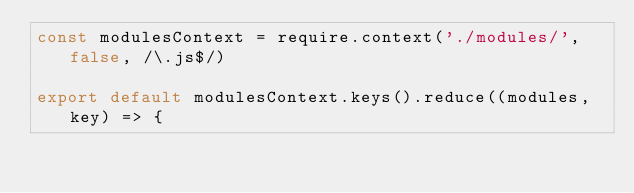Convert code to text. <code><loc_0><loc_0><loc_500><loc_500><_JavaScript_>const modulesContext = require.context('./modules/', false, /\.js$/)

export default modulesContext.keys().reduce((modules, key) => {</code> 